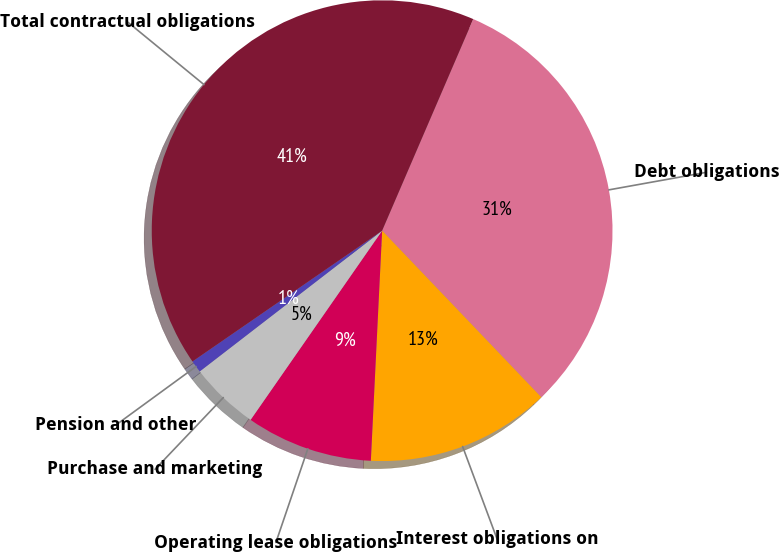Convert chart to OTSL. <chart><loc_0><loc_0><loc_500><loc_500><pie_chart><fcel>Debt obligations<fcel>Interest obligations on<fcel>Operating lease obligations<fcel>Purchase and marketing<fcel>Pension and other<fcel>Total contractual obligations<nl><fcel>31.39%<fcel>12.92%<fcel>8.89%<fcel>4.87%<fcel>0.85%<fcel>41.08%<nl></chart> 